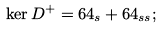<formula> <loc_0><loc_0><loc_500><loc_500>\ker D ^ { + } = 6 4 _ { s } + 6 4 _ { s s } ;</formula> 